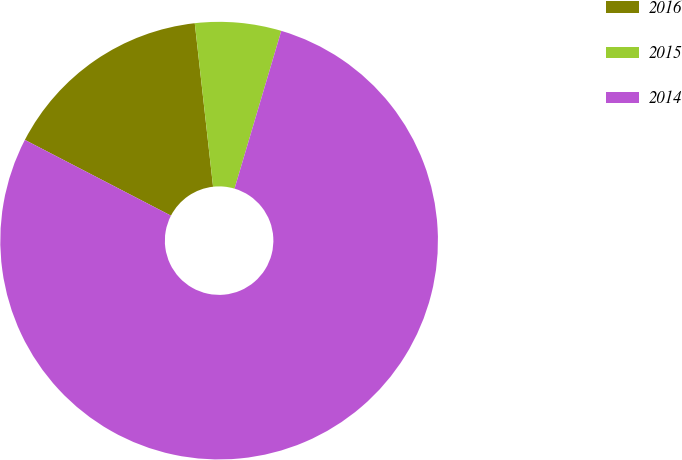<chart> <loc_0><loc_0><loc_500><loc_500><pie_chart><fcel>2016<fcel>2015<fcel>2014<nl><fcel>15.61%<fcel>6.36%<fcel>78.03%<nl></chart> 